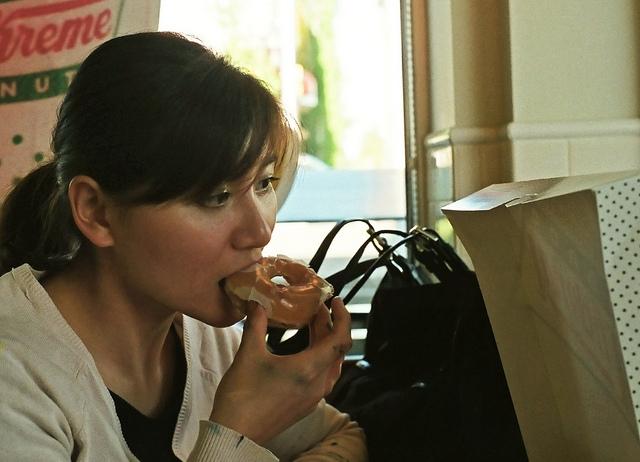Where are they?
Be succinct. Donut shop. Is the woman using her phone?
Write a very short answer. No. Is she wearing glasses?
Be succinct. No. How many women are here?
Write a very short answer. 1. What is she eating?
Answer briefly. Donut. Which wrist has a bracelet?
Be succinct. None. How many doughnuts are there?
Short answer required. 1. Is the woman outside the building?
Answer briefly. No. Is the girl wearing sunglasses?
Quick response, please. No. Is she on the phone?
Write a very short answer. No. What is the texture of this person's hair?
Be succinct. Straight. Is the BBW eating a doughnut?
Be succinct. Yes. What is the woman getting ready to eat?
Keep it brief. Donut. Is the girl drinking beer?
Write a very short answer. No. What is in the woman's mouth?
Short answer required. Donut. What color is her purse?
Write a very short answer. Black. Is the person a man or a woman?
Answer briefly. Woman. IS she smiling?
Short answer required. No. What is the lady eating?
Concise answer only. Donut. What is the woman holding?
Keep it brief. Donut. Is she having fun?
Give a very brief answer. No. What color is the woman's coat?
Give a very brief answer. White. What store is she in?
Short answer required. Krispy kreme. Is this woman kissing her lover?
Quick response, please. No. Is this woman eating in an animated fashion?
Give a very brief answer. No. What is above that woman's lip?
Quick response, please. Nose. What is this person eating?
Concise answer only. Donut. What is the woman biting into?
Concise answer only. Donut. How many sandwiches are there?
Answer briefly. 0. Was this photo taken at night?
Answer briefly. No. Does she think this donut will be tasty?
Be succinct. Yes. 